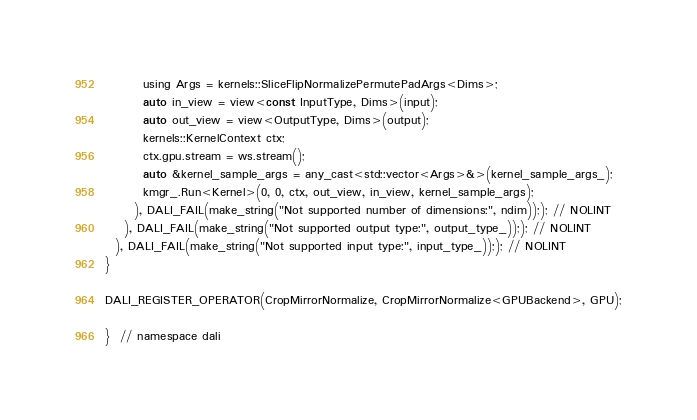Convert code to text. <code><loc_0><loc_0><loc_500><loc_500><_Cuda_>        using Args = kernels::SliceFlipNormalizePermutePadArgs<Dims>;
        auto in_view = view<const InputType, Dims>(input);
        auto out_view = view<OutputType, Dims>(output);
        kernels::KernelContext ctx;
        ctx.gpu.stream = ws.stream();
        auto &kernel_sample_args = any_cast<std::vector<Args>&>(kernel_sample_args_);
        kmgr_.Run<Kernel>(0, 0, ctx, out_view, in_view, kernel_sample_args);
      ), DALI_FAIL(make_string("Not supported number of dimensions:", ndim));); // NOLINT
    ), DALI_FAIL(make_string("Not supported output type:", output_type_));); // NOLINT
  ), DALI_FAIL(make_string("Not supported input type:", input_type_));); // NOLINT
}

DALI_REGISTER_OPERATOR(CropMirrorNormalize, CropMirrorNormalize<GPUBackend>, GPU);

}  // namespace dali
</code> 